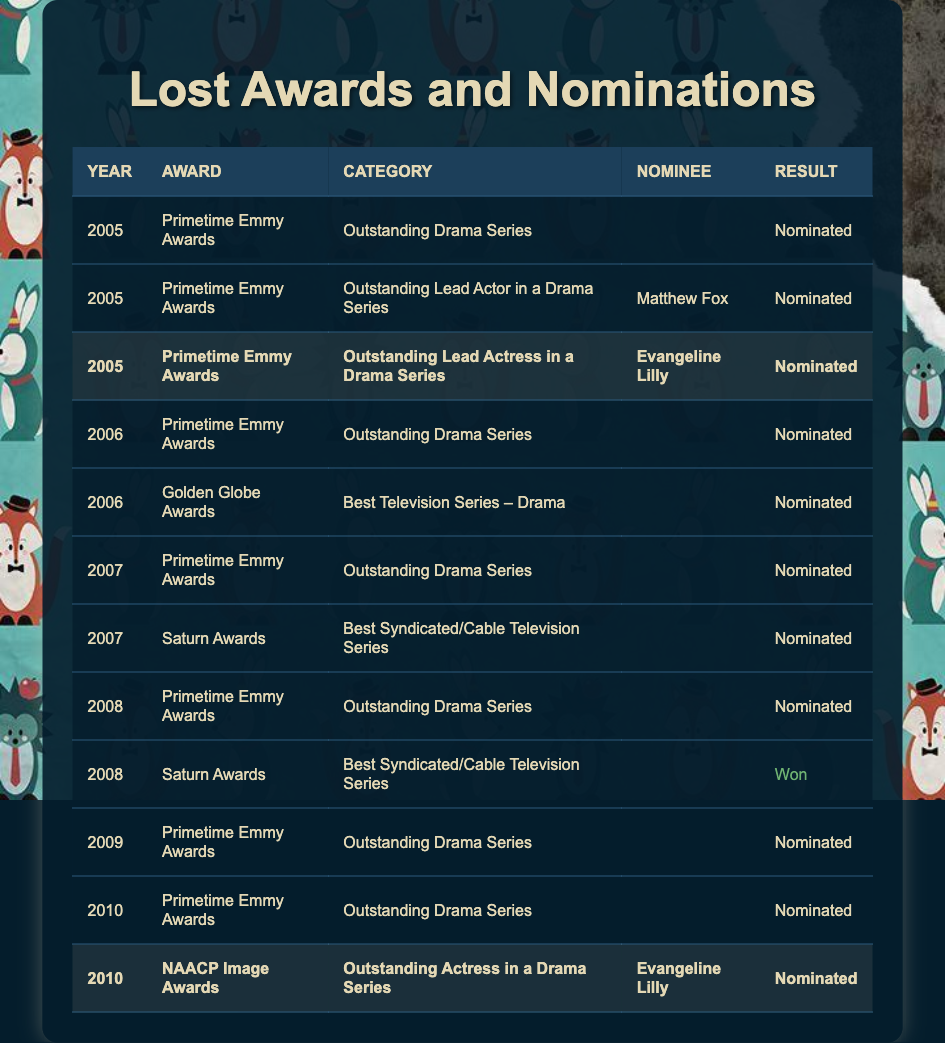What year did "Lost" win a Saturn Award? The table shows that "Lost" won a Saturn Award in 2008, specifically for the category of Best Syndicated/Cable Television Series.
Answer: 2008 How many times was "Lost" nominated for the Primetime Emmy Awards? By counting the nominations listed in the table, "Lost" was nominated for the Primetime Emmy Awards a total of five times (2005, 2006, 2007, 2008, 2009, and 2010).
Answer: 5 Did Evangeline Lilly receive a nomination for an Emmy in 2005? The table indicates that Evangeline Lilly was indeed nominated for the Primetime Emmy Awards in 2005 for Outstanding Lead Actress in a Drama Series.
Answer: Yes What is the total number of awards and nominations listed in the table? There are 11 entries in the table that represent various nominations and one win (the Saturn Award in 2008), totaling 11.
Answer: 11 In which categories was Evangeline Lilly nominated? The table lists her nominations specifically in the categories of Outstanding Lead Actress in a Drama Series at the Primetime Emmy Awards (2005) and Outstanding Actress in a Drama Series at the NAACP Image Awards (2010).
Answer: Two categories Which award had the most nominations for "Lost"? Upon reviewing, the Primetime Emmy Awards had the most nominations for "Lost" with a total of six nominations spanning from 2005 to 2010.
Answer: Primetime Emmy Awards Was there any year where "Lost" was both nominated and won an award? Looking through the table, in 2008, "Lost" was nominated for the Primetime Emmy Awards but won the Saturn Award, making this a year with both a nomination and a win.
Answer: Yes How many nominations did "Lost" receive for lead acting categories? The table shows that "Lost" received two nominations in lead acting categories: one for Evangeline Lilly in 2005 and one for Matthew Fox in the same year.
Answer: 2 What percentage of the ceremonies listed resulted in wins for "Lost"? "Lost" has one win (2008 Saturn Awards) out of a total of 11 entries. The calculation is (1 win / 11 total) * 100 = approximately 9.09%.
Answer: 9.09% In which year did "Lost" receive its first Emmy nomination? The first nomination for "Lost" at the Primetime Emmy Awards was in 2005, as shown in the table.
Answer: 2005 